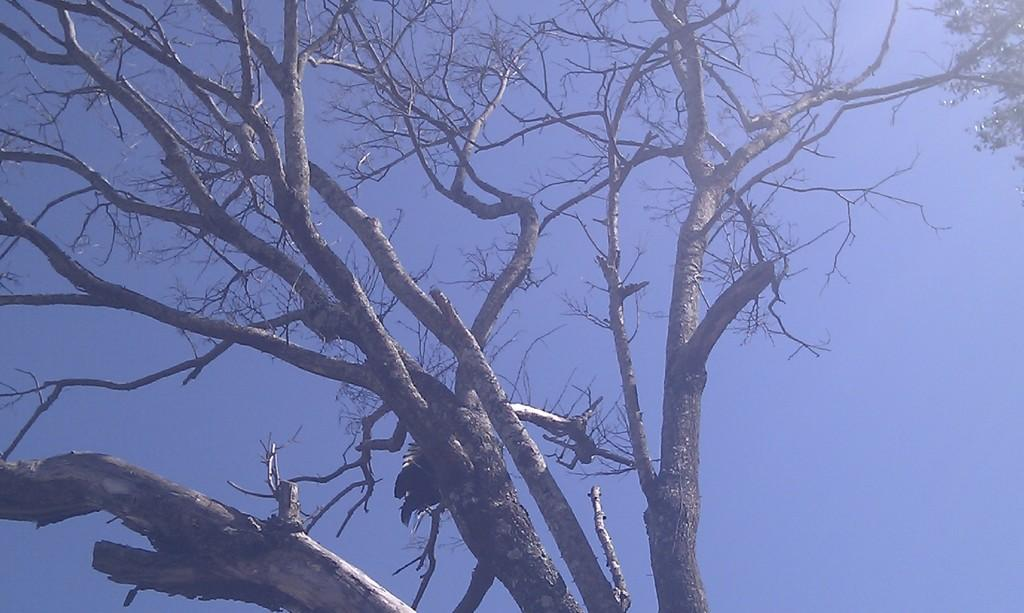What type of vegetation can be seen in the image? There is a tree without leaves and a tree with leaves in the image. Where is the tree with leaves located in the image? The tree with leaves is on the right side of the image. What is visible at the top of the image? The sky is visible at the top of the image. What type of punishment is being administered to the tree without leaves in the image? There is no punishment being administered to the tree without leaves in the image. How many chairs are visible in the image? There is: There are no chairs present in the image. 